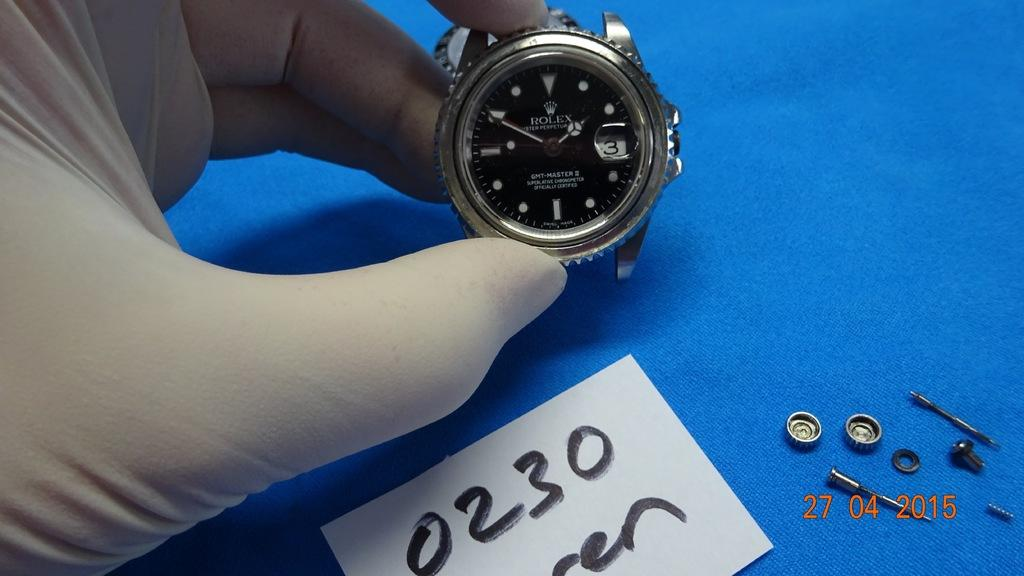<image>
Create a compact narrative representing the image presented. Person holding a watch that has a piece of paper which says 0230 on it. 